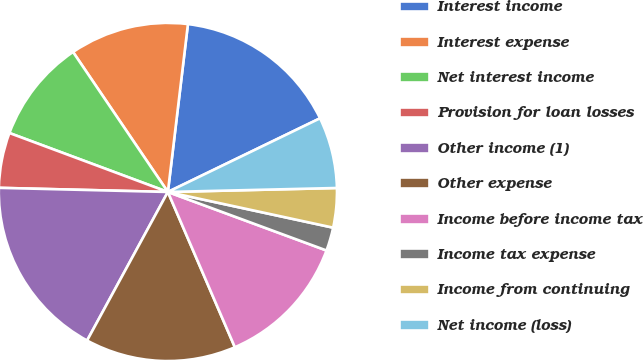<chart> <loc_0><loc_0><loc_500><loc_500><pie_chart><fcel>Interest income<fcel>Interest expense<fcel>Net interest income<fcel>Provision for loan losses<fcel>Other income (1)<fcel>Other expense<fcel>Income before income tax<fcel>Income tax expense<fcel>Income from continuing<fcel>Net income (loss)<nl><fcel>15.93%<fcel>11.37%<fcel>9.85%<fcel>5.28%<fcel>17.46%<fcel>14.41%<fcel>12.89%<fcel>2.24%<fcel>3.76%<fcel>6.8%<nl></chart> 